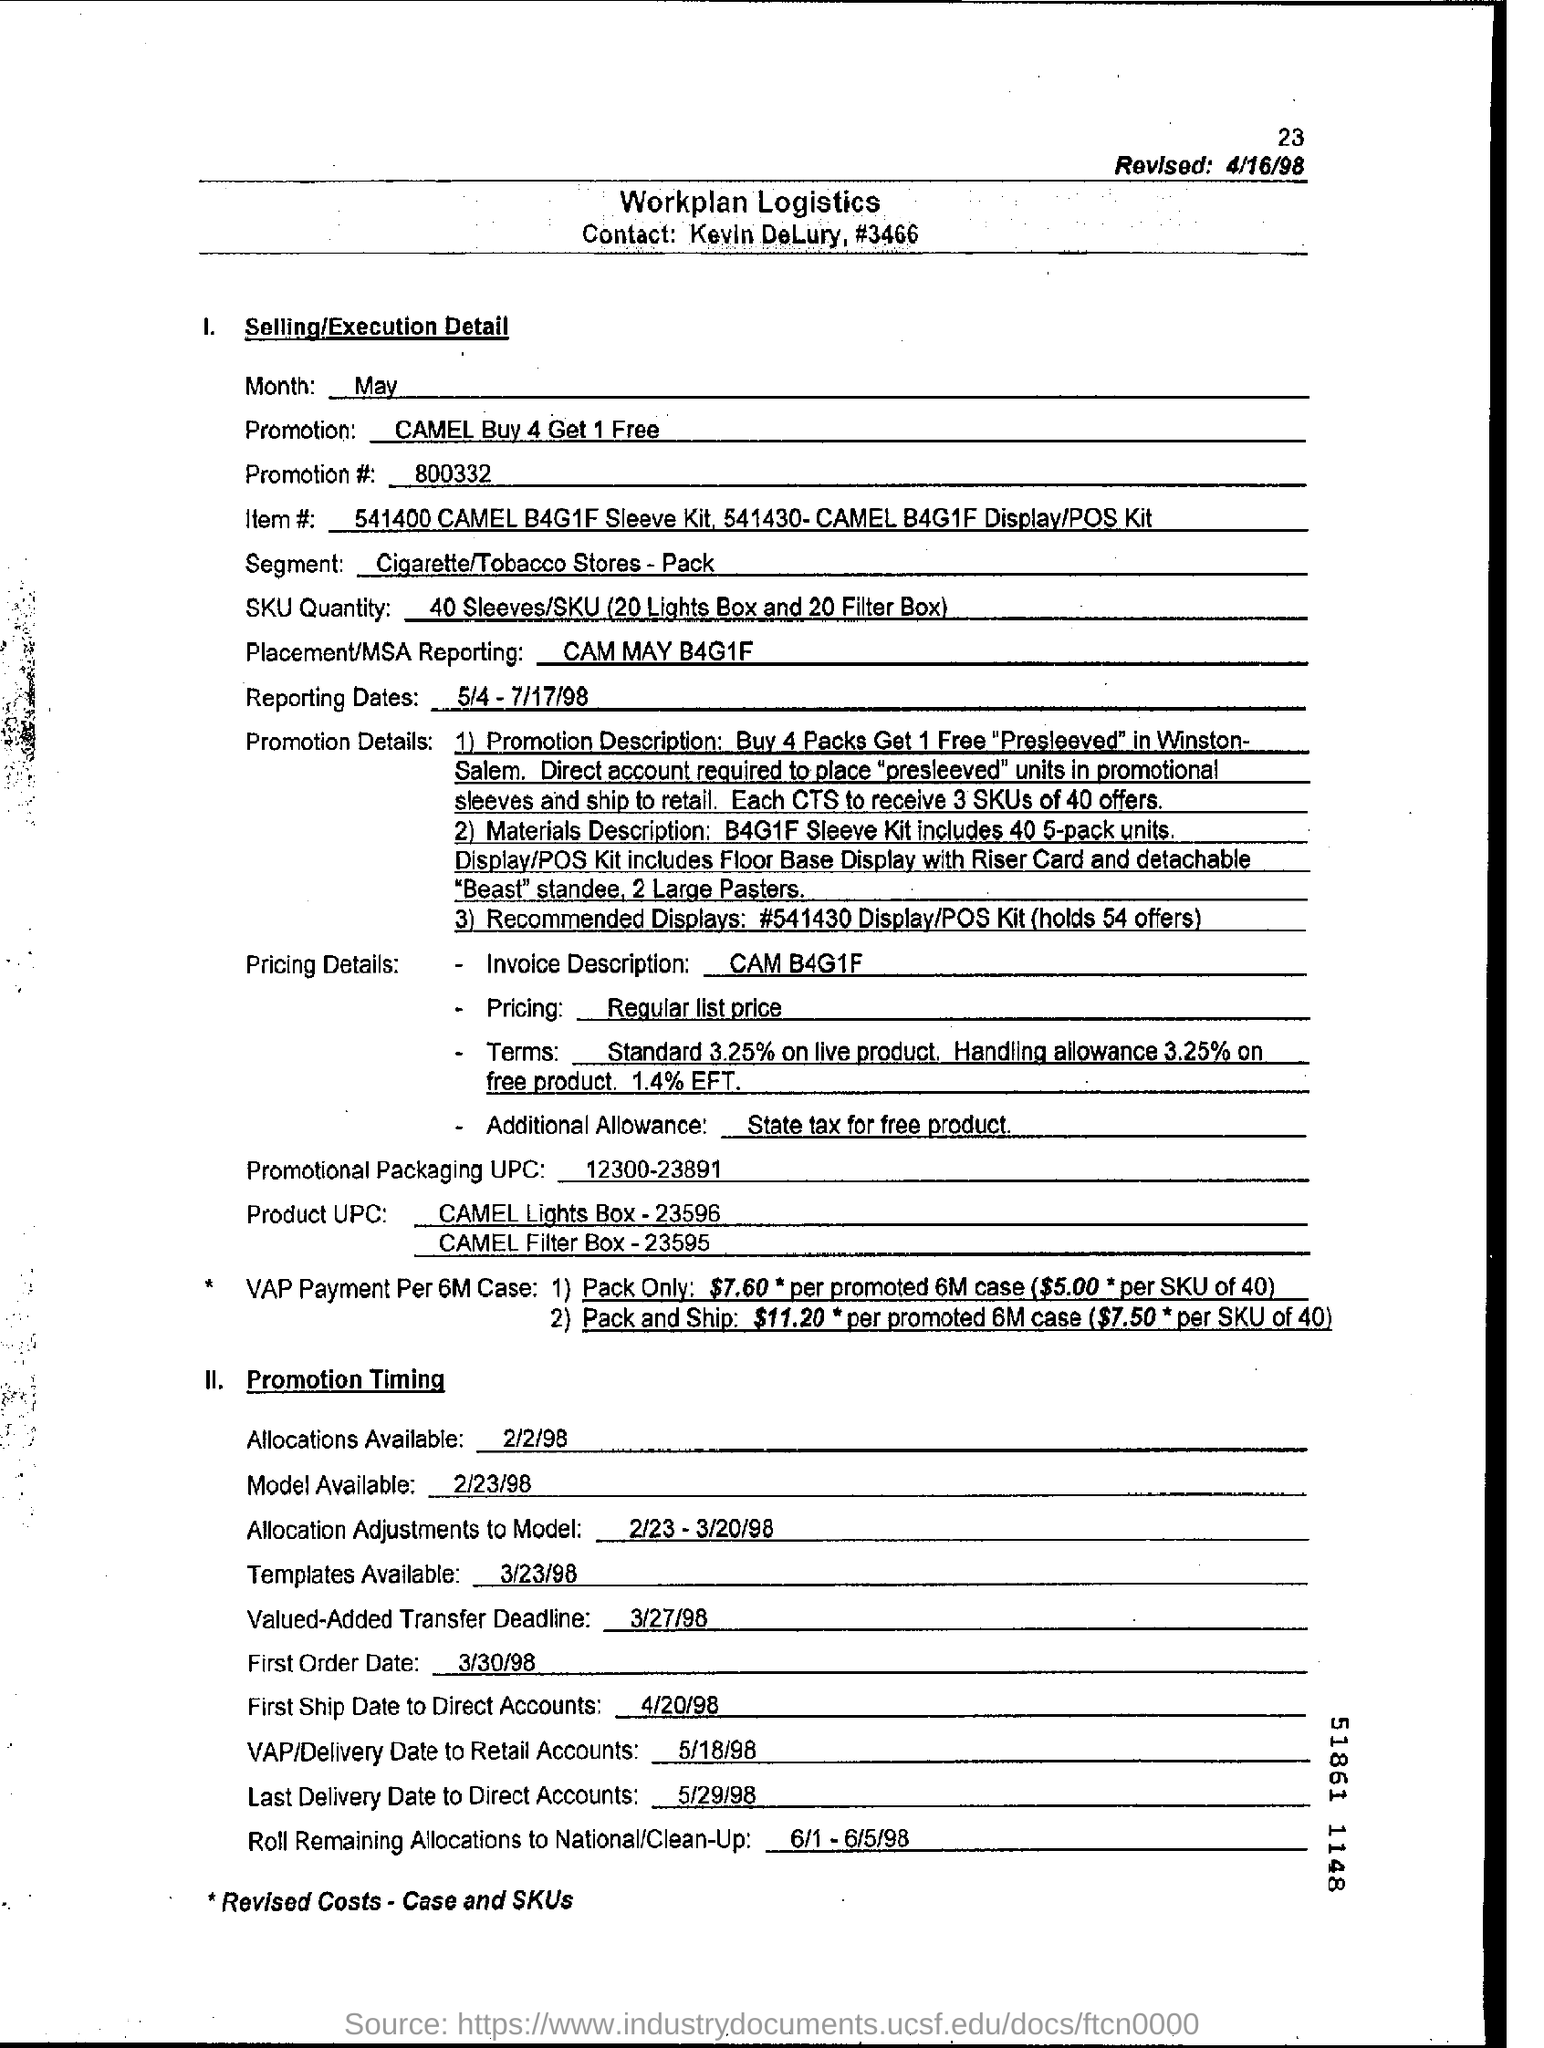What is the Promotion #? The promotion number, as indicated on the document, is 800332. This promotion involves a 'Buy 4 Get 1 Free' offer as stated in the Selling/Execution Detail section. 